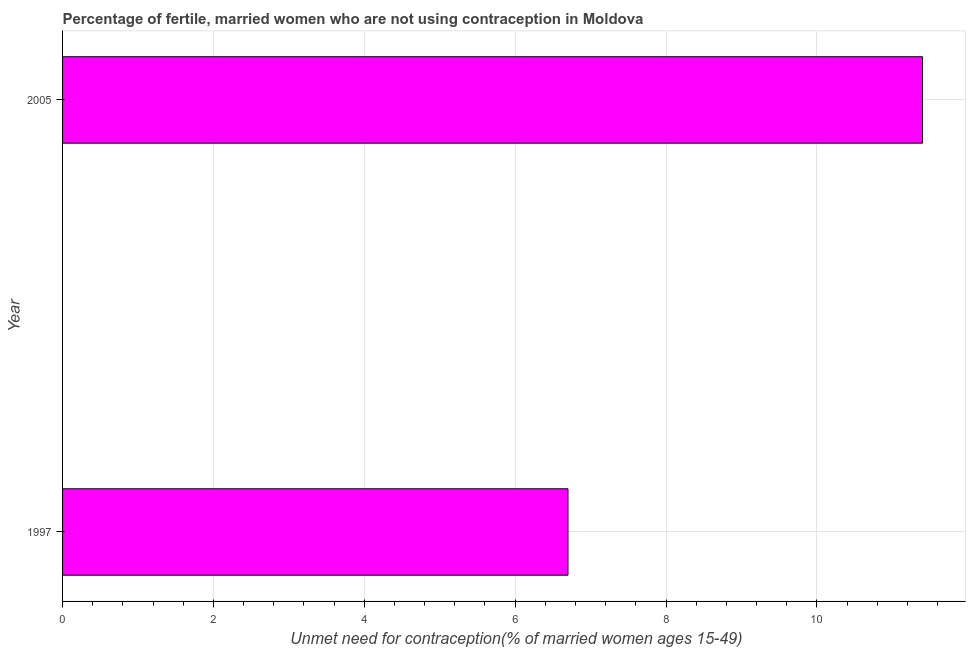Does the graph contain grids?
Your response must be concise. Yes. What is the title of the graph?
Provide a short and direct response. Percentage of fertile, married women who are not using contraception in Moldova. What is the label or title of the X-axis?
Offer a very short reply.  Unmet need for contraception(% of married women ages 15-49). Across all years, what is the minimum number of married women who are not using contraception?
Keep it short and to the point. 6.7. In which year was the number of married women who are not using contraception maximum?
Provide a short and direct response. 2005. In which year was the number of married women who are not using contraception minimum?
Offer a very short reply. 1997. What is the sum of the number of married women who are not using contraception?
Your answer should be compact. 18.1. What is the difference between the number of married women who are not using contraception in 1997 and 2005?
Offer a terse response. -4.7. What is the average number of married women who are not using contraception per year?
Offer a terse response. 9.05. What is the median number of married women who are not using contraception?
Your answer should be very brief. 9.05. In how many years, is the number of married women who are not using contraception greater than 2 %?
Make the answer very short. 2. Do a majority of the years between 1997 and 2005 (inclusive) have number of married women who are not using contraception greater than 10.8 %?
Offer a very short reply. No. What is the ratio of the number of married women who are not using contraception in 1997 to that in 2005?
Your answer should be very brief. 0.59. Is the number of married women who are not using contraception in 1997 less than that in 2005?
Keep it short and to the point. Yes. In how many years, is the number of married women who are not using contraception greater than the average number of married women who are not using contraception taken over all years?
Ensure brevity in your answer.  1. How many bars are there?
Ensure brevity in your answer.  2. Are all the bars in the graph horizontal?
Your answer should be compact. Yes. What is the  Unmet need for contraception(% of married women ages 15-49) of 1997?
Ensure brevity in your answer.  6.7. What is the  Unmet need for contraception(% of married women ages 15-49) in 2005?
Your response must be concise. 11.4. What is the ratio of the  Unmet need for contraception(% of married women ages 15-49) in 1997 to that in 2005?
Keep it short and to the point. 0.59. 